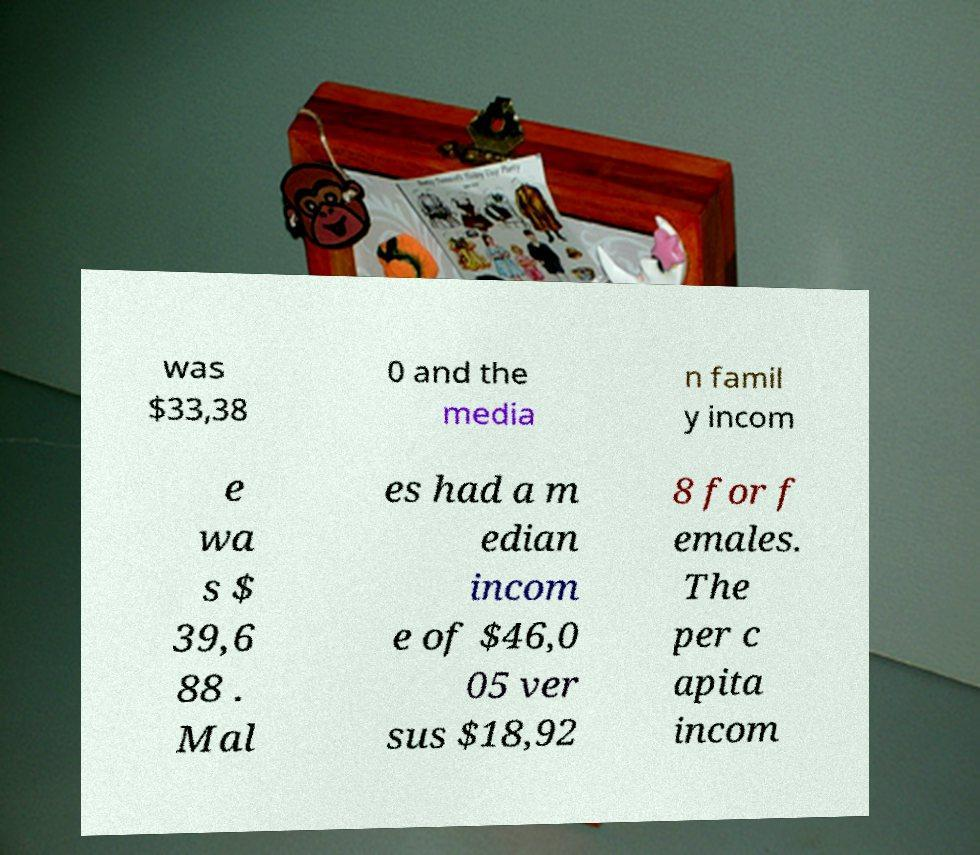Please read and relay the text visible in this image. What does it say? was $33,38 0 and the media n famil y incom e wa s $ 39,6 88 . Mal es had a m edian incom e of $46,0 05 ver sus $18,92 8 for f emales. The per c apita incom 